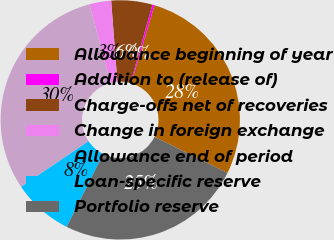Convert chart. <chart><loc_0><loc_0><loc_500><loc_500><pie_chart><fcel>Allowance beginning of year<fcel>Addition to (release of)<fcel>Charge-offs net of recoveries<fcel>Change in foreign exchange<fcel>Allowance end of period<fcel>Loan-specific reserve<fcel>Portfolio reserve<nl><fcel>27.7%<fcel>0.29%<fcel>5.54%<fcel>2.92%<fcel>30.32%<fcel>8.16%<fcel>25.07%<nl></chart> 